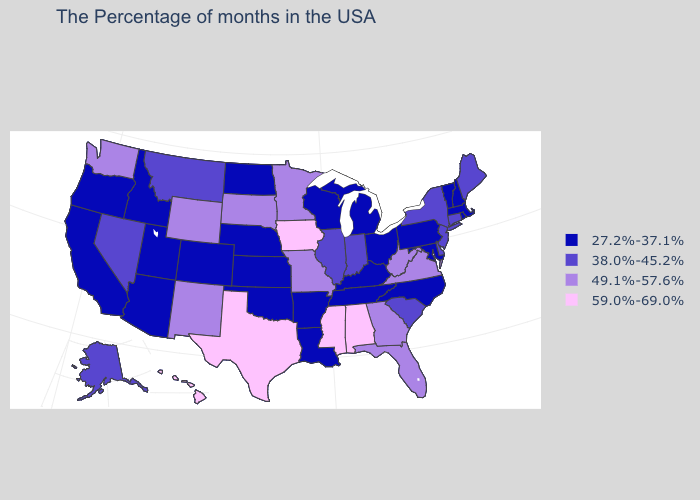How many symbols are there in the legend?
Write a very short answer. 4. What is the value of Alaska?
Be succinct. 38.0%-45.2%. Which states have the lowest value in the USA?
Short answer required. Massachusetts, Rhode Island, New Hampshire, Vermont, Maryland, Pennsylvania, North Carolina, Ohio, Michigan, Kentucky, Tennessee, Wisconsin, Louisiana, Arkansas, Kansas, Nebraska, Oklahoma, North Dakota, Colorado, Utah, Arizona, Idaho, California, Oregon. Does North Dakota have the lowest value in the USA?
Give a very brief answer. Yes. What is the lowest value in states that border Texas?
Keep it brief. 27.2%-37.1%. Does North Carolina have the highest value in the USA?
Be succinct. No. What is the value of Ohio?
Answer briefly. 27.2%-37.1%. Among the states that border Washington , which have the highest value?
Give a very brief answer. Idaho, Oregon. Name the states that have a value in the range 49.1%-57.6%?
Give a very brief answer. Virginia, West Virginia, Florida, Georgia, Missouri, Minnesota, South Dakota, Wyoming, New Mexico, Washington. Name the states that have a value in the range 59.0%-69.0%?
Keep it brief. Alabama, Mississippi, Iowa, Texas, Hawaii. What is the value of Wisconsin?
Quick response, please. 27.2%-37.1%. Is the legend a continuous bar?
Be succinct. No. Does the first symbol in the legend represent the smallest category?
Answer briefly. Yes. Which states have the lowest value in the USA?
Concise answer only. Massachusetts, Rhode Island, New Hampshire, Vermont, Maryland, Pennsylvania, North Carolina, Ohio, Michigan, Kentucky, Tennessee, Wisconsin, Louisiana, Arkansas, Kansas, Nebraska, Oklahoma, North Dakota, Colorado, Utah, Arizona, Idaho, California, Oregon. Among the states that border Texas , which have the highest value?
Be succinct. New Mexico. 